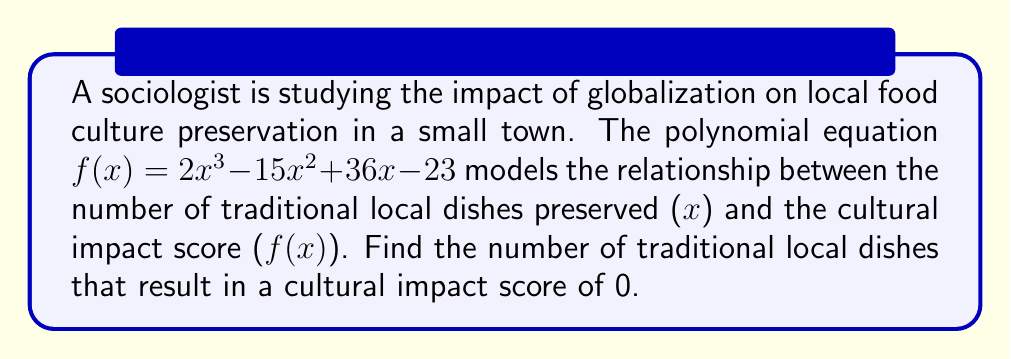Teach me how to tackle this problem. To solve this problem, we need to find the roots of the polynomial equation $f(x) = 0$. Let's approach this step-by-step:

1) Set up the equation:
   $2x^3 - 15x^2 + 36x - 23 = 0$

2) This is a cubic equation. Let's try to factor it:
   First, check if there's a rational root using the rational root theorem.
   Possible rational roots are factors of 23: ±1, ±23

3) By testing these values, we find that x = 1 is a root.

4) Divide the polynomial by (x - 1):
   $2x^3 - 15x^2 + 36x - 23 = (x - 1)(2x^2 - 13x + 23)$

5) Now we have a quadratic equation to solve: $2x^2 - 13x + 23 = 0$

6) Use the quadratic formula: $x = \frac{-b \pm \sqrt{b^2 - 4ac}}{2a}$
   Where $a = 2$, $b = -13$, and $c = 23$

7) Plugging in these values:
   $x = \frac{13 \pm \sqrt{169 - 184}}{4} = \frac{13 \pm \sqrt{-15}}{4}$

8) Since $\sqrt{-15}$ is not a real number, the quadratic has no real roots.

Therefore, the only real solution to the equation is x = 1.
Answer: The equation has one real solution: x = 1. This means that preserving 1 traditional local dish results in a cultural impact score of 0. 